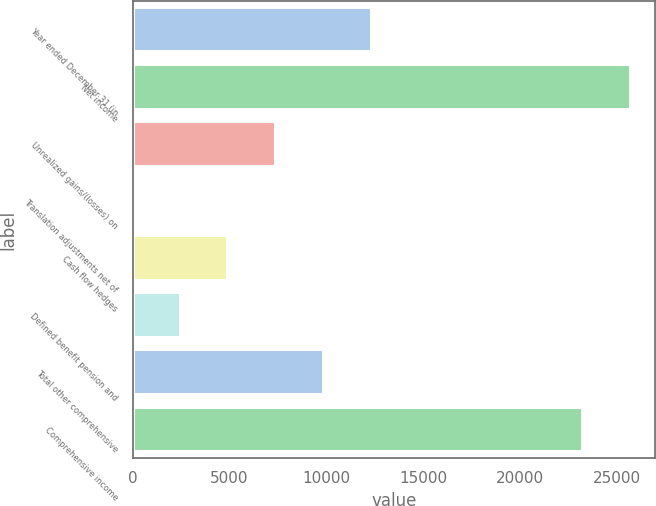Convert chart. <chart><loc_0><loc_0><loc_500><loc_500><bar_chart><fcel>Year ended December 31 (in<fcel>Net income<fcel>Unrealized gains/(losses) on<fcel>Translation adjustments net of<fcel>Cash flow hedges<fcel>Defined benefit pension and<fcel>Total other comprehensive<fcel>Comprehensive income<nl><fcel>12367.5<fcel>25685.1<fcel>7421.3<fcel>2<fcel>4948.2<fcel>2475.1<fcel>9894.4<fcel>23212<nl></chart> 